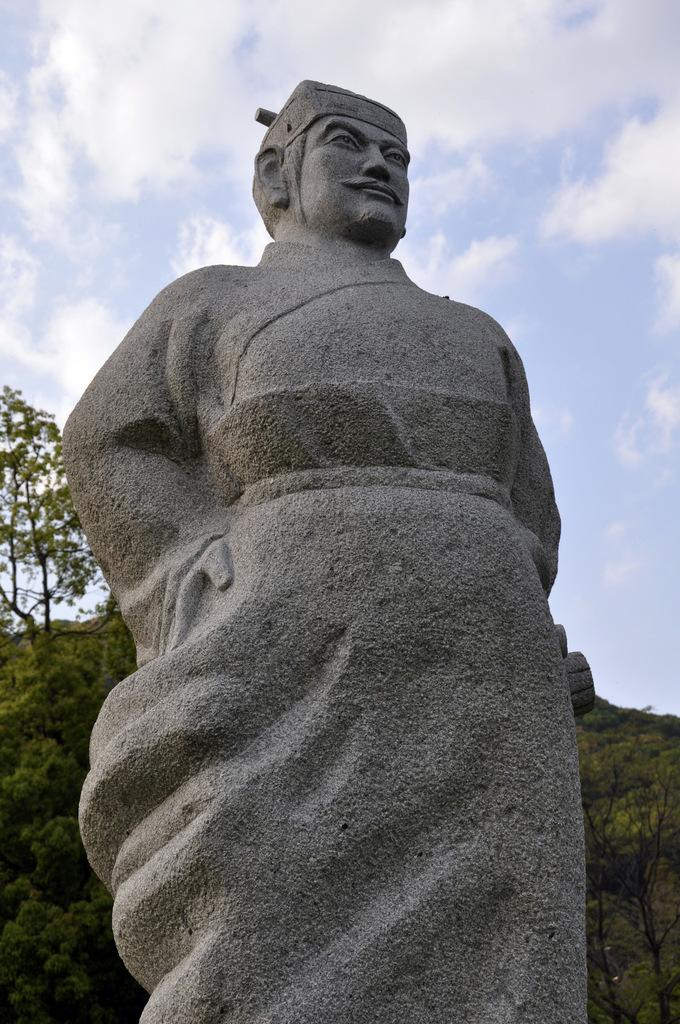What is the main subject in the image? There is a statue in the image. What can be seen in the background of the image? There are trees and the sky visible in the background of the image. What is the condition of the sky in the image? Clouds are present in the sky. What type of office equipment can be seen on the statue in the image? There is no office equipment present on the statue in the image. What day of the week is depicted in the image? The image does not depict a specific day of the week. 